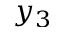<formula> <loc_0><loc_0><loc_500><loc_500>y _ { 3 }</formula> 